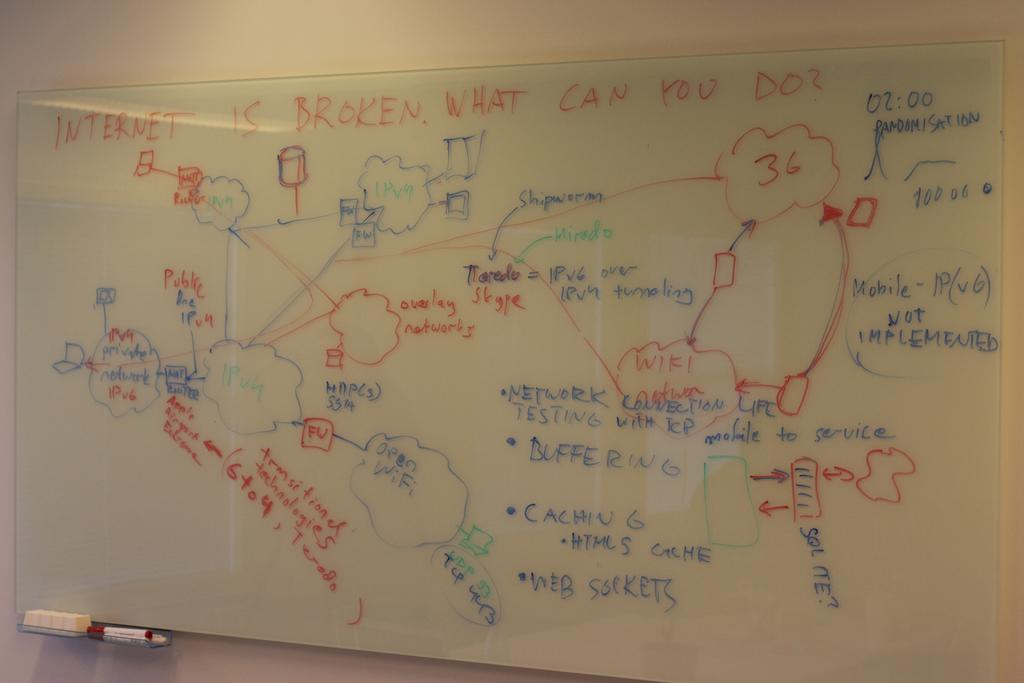What is the main object in the image? There is a big whiteboard in the image. How is the whiteboard positioned in the image? The whiteboard is attached to the wall. What can be seen on the whiteboard? There is text on the whiteboard. Are there any tools attached to the whiteboard? Yes, there is a marker and a duster attached to the whiteboard. What type of polish is used to maintain the whiteboard in the image? There is no mention of polish being used to maintain the whiteboard in the image. What is the end goal of the idea written on the whiteboard? The image does not provide any information about the purpose or goal of the idea written on the whiteboard. 